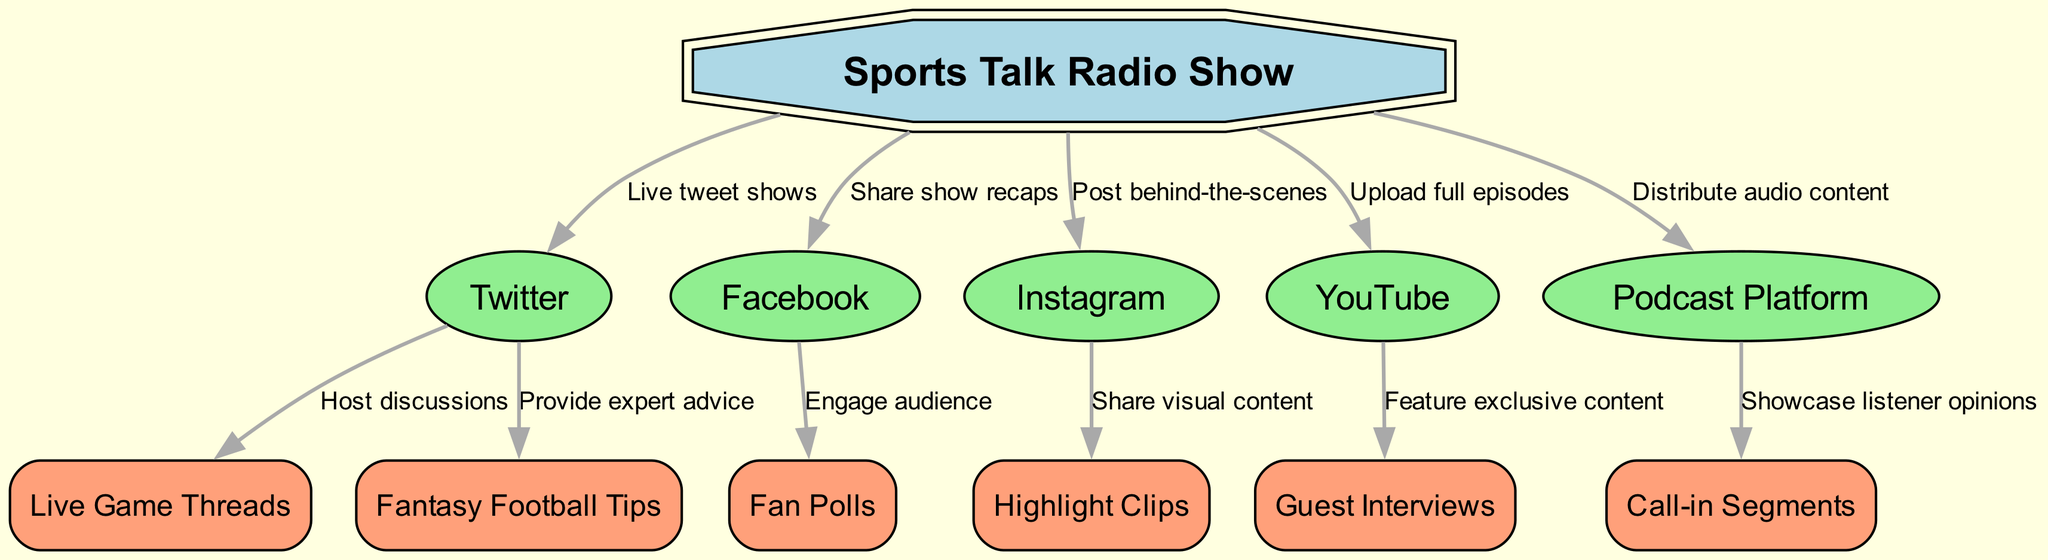What is the total number of nodes in the graph? The diagram contains a total of 12 unique entities represented as nodes, which can be counted through the node list in the data provided.
Answer: 12 Which platform is connected to "Live Game Threads"? The directed edge shows that "Twitter" is the platform that connects to "Live Game Threads", as indicated in the edges section.
Answer: Twitter What type of content is shared through Instagram? The diagram indicates that "Highlight Clips" are shared through "Instagram", as shown by the directed edge connection.
Answer: Highlight Clips How many edges are originating from the "Sports Talk Radio Show"? By examining the diagram, there are 5 edges that originate from the "Sports Talk Radio Show", leading to various platforms, which are listed in the edges section.
Answer: 5 Which social media platform is associated with engaging the audience via fan polls? The directed edge reveals that "Facebook" is associated with engaging the audience through "Fan Polls."
Answer: Facebook What does "YouTube" feature that is exclusive compared to other platforms? The data shows that "YouTube" features "Guest Interviews", which is a distinct type of content not listed for other platforms.
Answer: Guest Interviews Which two nodes are directly connected to "Twitter"? The edges indicate that "Live Game Threads" and "Fantasy Football Tips" are both directly connected to "Twitter," as seen in the connections from the Twitter node.
Answer: Live Game Threads, Fantasy Football Tips What type of content is uploaded to "YouTube"? The content described in the diagram that is uploaded to "YouTube" includes the "full episodes" of the sports talk radio show, as indicated by the labeled edge.
Answer: Full episodes Which node represents the main entity in the strategy? The main entity represented in the diagram is "Sports Talk Radio Show," as it is the central node from which most other nodes branch out.
Answer: Sports Talk Radio Show 